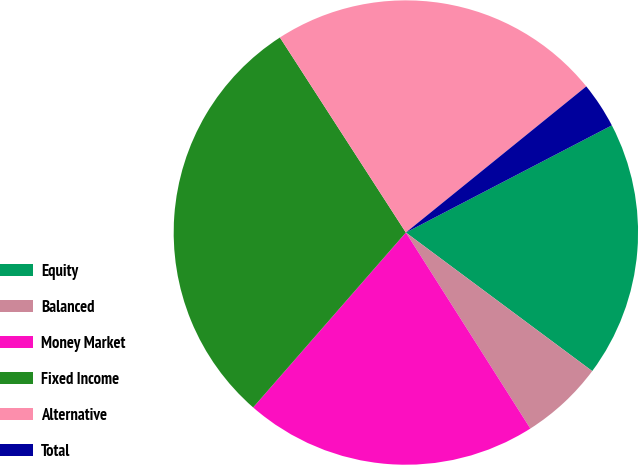<chart> <loc_0><loc_0><loc_500><loc_500><pie_chart><fcel>Equity<fcel>Balanced<fcel>Money Market<fcel>Fixed Income<fcel>Alternative<fcel>Total<nl><fcel>17.81%<fcel>5.82%<fcel>20.43%<fcel>29.45%<fcel>23.29%<fcel>3.2%<nl></chart> 